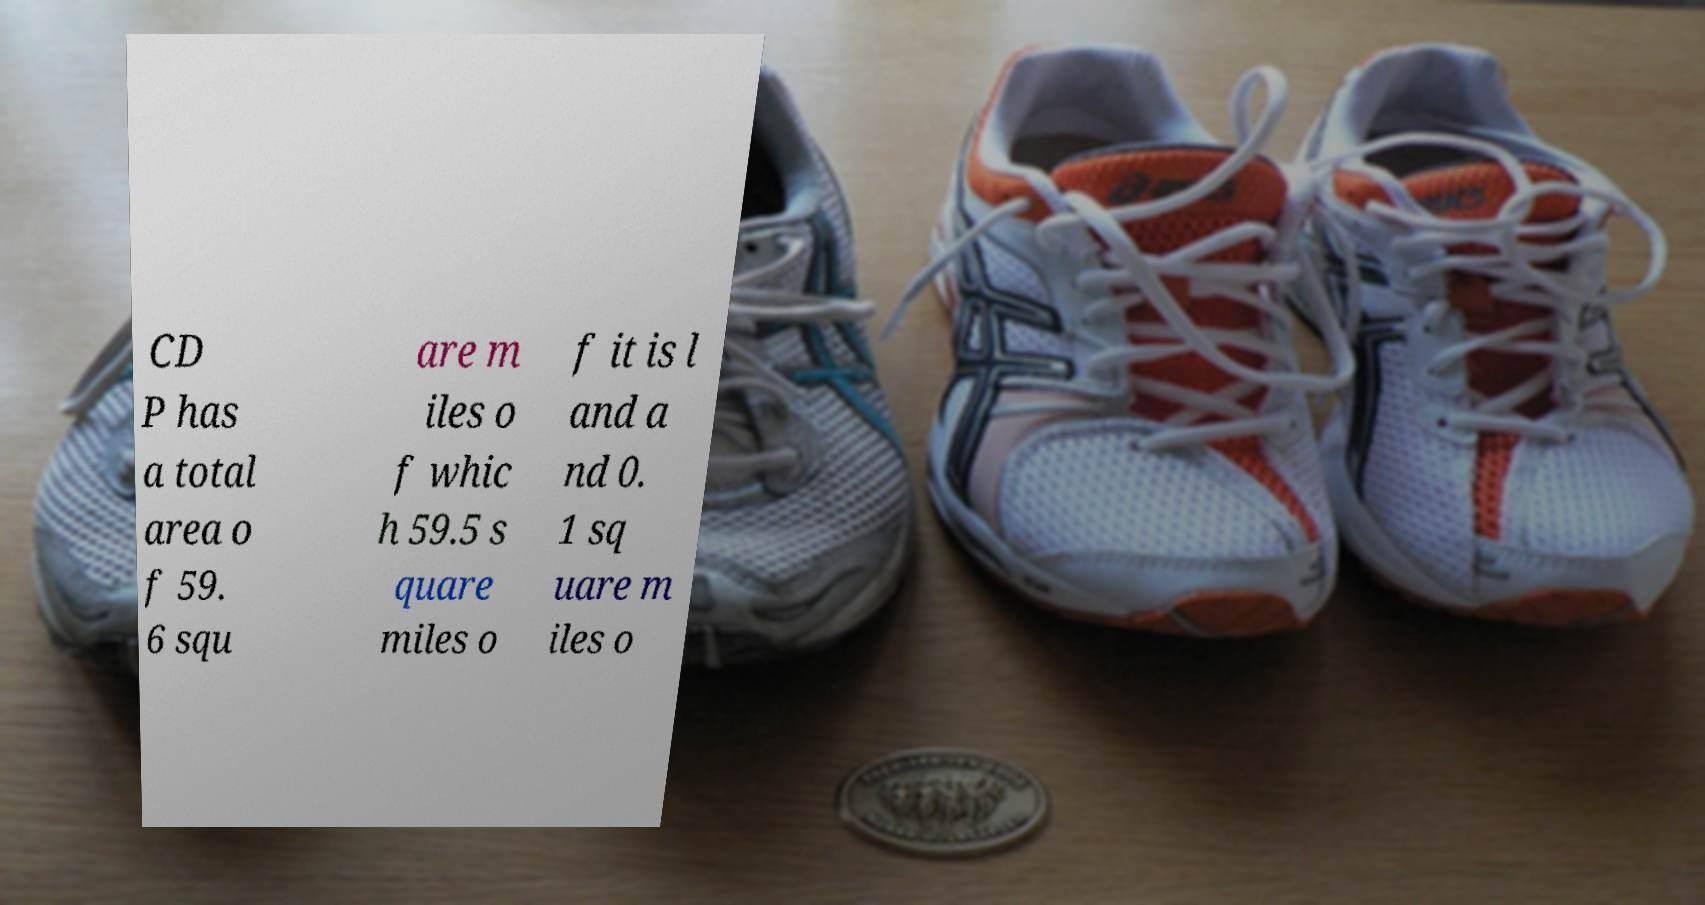Could you assist in decoding the text presented in this image and type it out clearly? CD P has a total area o f 59. 6 squ are m iles o f whic h 59.5 s quare miles o f it is l and a nd 0. 1 sq uare m iles o 